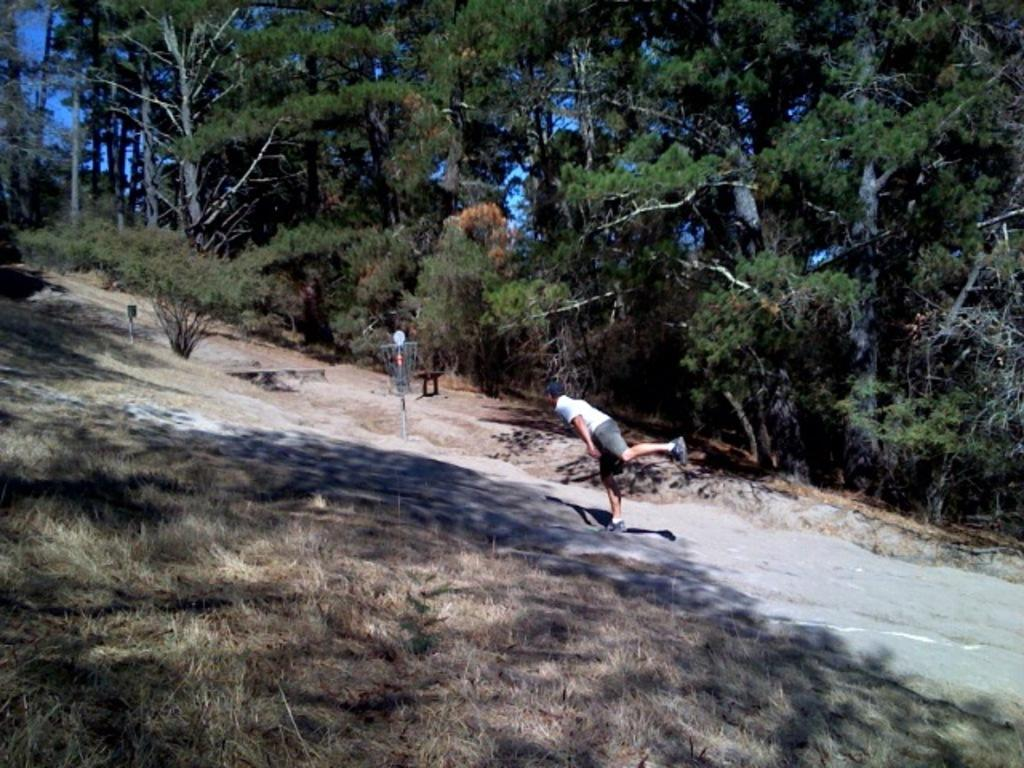Who or what is present in the image? There is a person in the image. What can be found on the ground in the image? There are objects on the ground in the image. How would you describe the color of the sky in the image? The sky is blue in the image. What type of natural environment is depicted in the image? There are many trees and plants in the image, suggesting a forest or park setting. What is the value of the nut that is hidden in the image? There is no nut present in the image, so it is not possible to determine its value. 